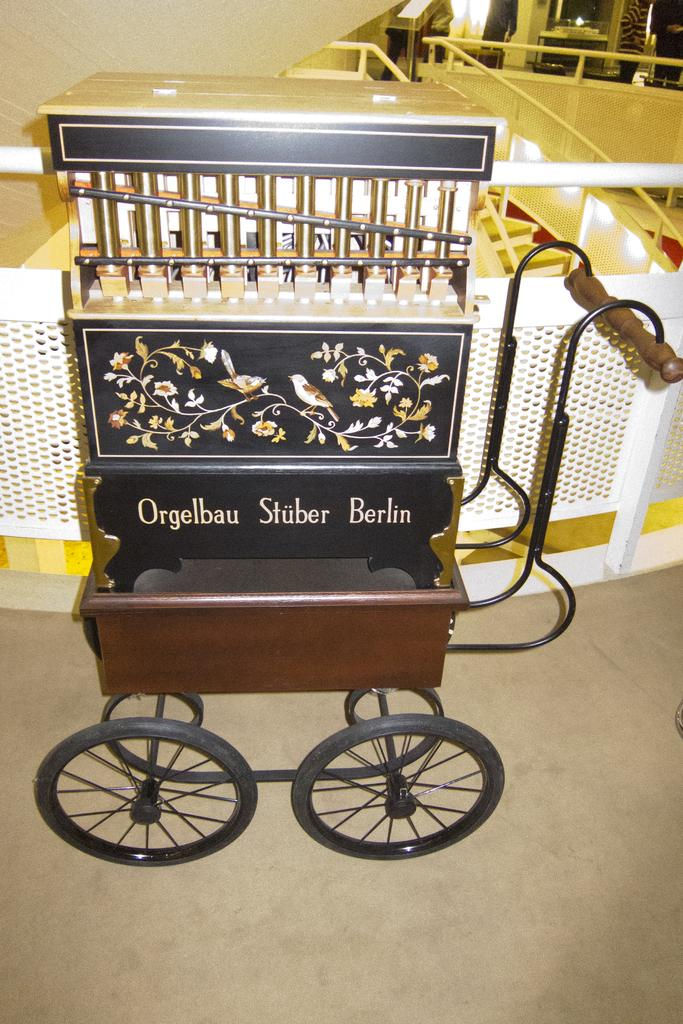What is the main object in the center of the image? There is a musical instrument in the center of the image. What can be seen in the background of the image? There are railings and tables in the background of the image. What is visible at the bottom of the image? There is a floor visible at the bottom of the image. What letter is being burned in the image? There is no letter being burned in the image; the image features a musical instrument, railings, tables, and a floor. 